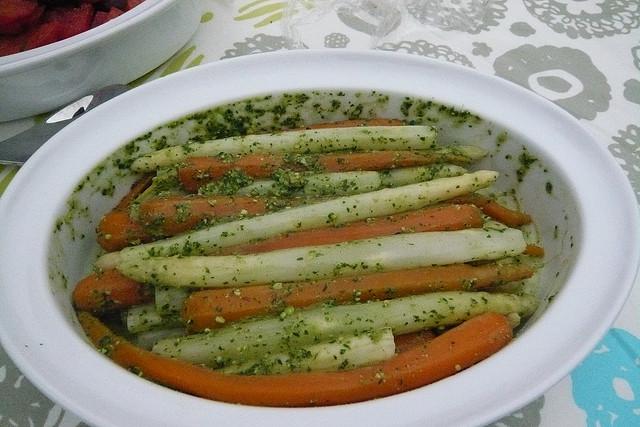What kind of vegetables are in the bowl?
Answer briefly. Carrots. What seasoning is on the vegetables?
Answer briefly. Oregano. What type of vegetable is in this bowl?
Concise answer only. Carrots. What color is the bowl?
Short answer required. White. 